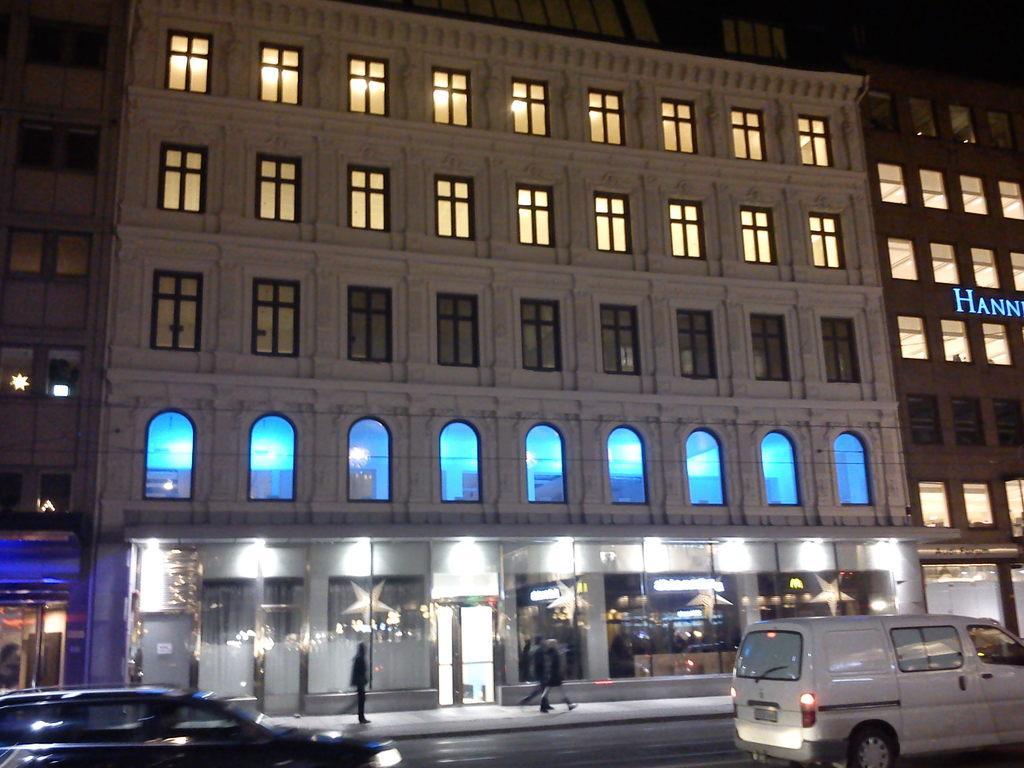Can you describe this image briefly? In this image we can see a building, there are some windows, vehicles, stars, doors and persons, on the building we can see the text. 